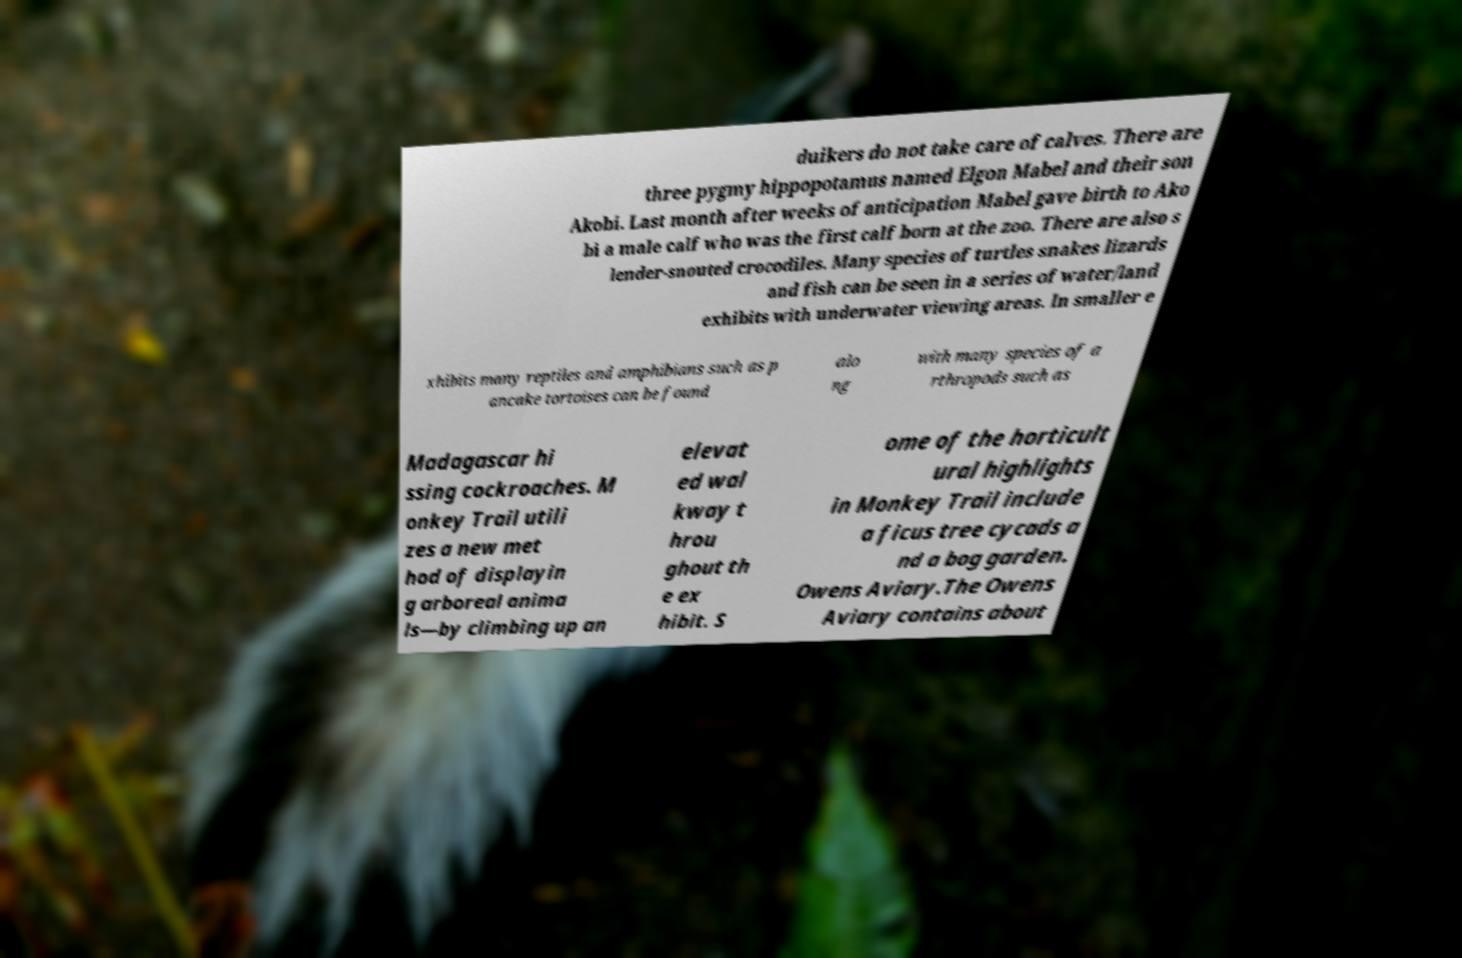Can you accurately transcribe the text from the provided image for me? duikers do not take care of calves. There are three pygmy hippopotamus named Elgon Mabel and their son Akobi. Last month after weeks of anticipation Mabel gave birth to Ako bi a male calf who was the first calf born at the zoo. There are also s lender-snouted crocodiles. Many species of turtles snakes lizards and fish can be seen in a series of water/land exhibits with underwater viewing areas. In smaller e xhibits many reptiles and amphibians such as p ancake tortoises can be found alo ng with many species of a rthropods such as Madagascar hi ssing cockroaches. M onkey Trail utili zes a new met hod of displayin g arboreal anima ls—by climbing up an elevat ed wal kway t hrou ghout th e ex hibit. S ome of the horticult ural highlights in Monkey Trail include a ficus tree cycads a nd a bog garden. Owens Aviary.The Owens Aviary contains about 